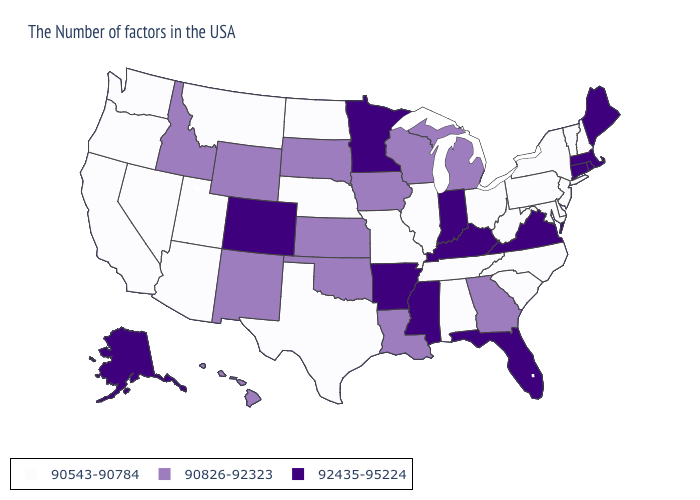Does Wisconsin have a higher value than West Virginia?
Quick response, please. Yes. Is the legend a continuous bar?
Give a very brief answer. No. Name the states that have a value in the range 90543-90784?
Short answer required. New Hampshire, Vermont, New York, New Jersey, Delaware, Maryland, Pennsylvania, North Carolina, South Carolina, West Virginia, Ohio, Alabama, Tennessee, Illinois, Missouri, Nebraska, Texas, North Dakota, Utah, Montana, Arizona, Nevada, California, Washington, Oregon. Does the first symbol in the legend represent the smallest category?
Be succinct. Yes. Which states hav the highest value in the Northeast?
Short answer required. Maine, Massachusetts, Rhode Island, Connecticut. Among the states that border Montana , does North Dakota have the highest value?
Write a very short answer. No. What is the value of Kentucky?
Keep it brief. 92435-95224. Does the first symbol in the legend represent the smallest category?
Be succinct. Yes. How many symbols are there in the legend?
Quick response, please. 3. How many symbols are there in the legend?
Give a very brief answer. 3. Name the states that have a value in the range 90826-92323?
Write a very short answer. Georgia, Michigan, Wisconsin, Louisiana, Iowa, Kansas, Oklahoma, South Dakota, Wyoming, New Mexico, Idaho, Hawaii. How many symbols are there in the legend?
Quick response, please. 3. Name the states that have a value in the range 90543-90784?
Write a very short answer. New Hampshire, Vermont, New York, New Jersey, Delaware, Maryland, Pennsylvania, North Carolina, South Carolina, West Virginia, Ohio, Alabama, Tennessee, Illinois, Missouri, Nebraska, Texas, North Dakota, Utah, Montana, Arizona, Nevada, California, Washington, Oregon. Name the states that have a value in the range 90826-92323?
Short answer required. Georgia, Michigan, Wisconsin, Louisiana, Iowa, Kansas, Oklahoma, South Dakota, Wyoming, New Mexico, Idaho, Hawaii. What is the highest value in states that border Indiana?
Quick response, please. 92435-95224. 